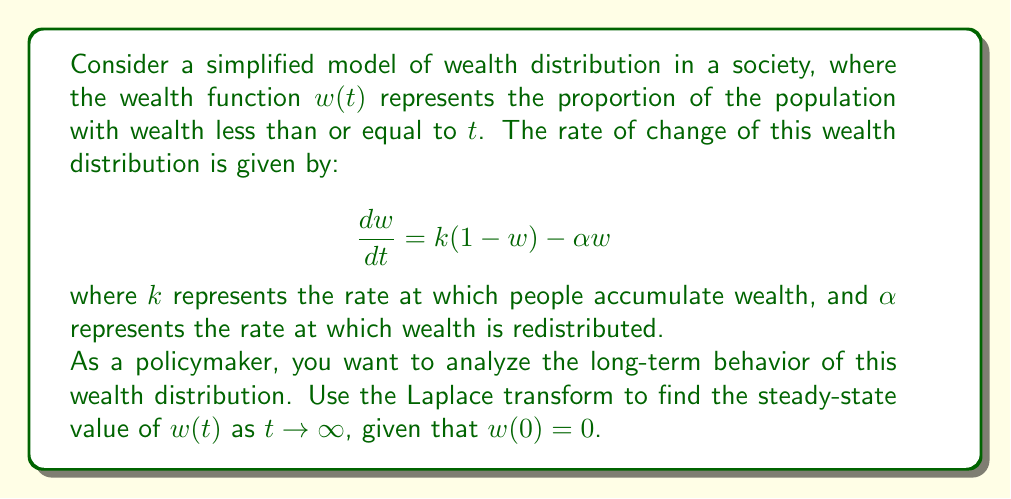Can you answer this question? To solve this problem, we'll use the Laplace transform method:

1) First, let's take the Laplace transform of both sides of the differential equation:

   $\mathcal{L}\{\frac{dw}{dt}\} = \mathcal{L}\{k(1-w) - \alpha w\}$

2) Using the linearity property and the Laplace transform of a derivative:

   $sW(s) - w(0) = \frac{k}{s} - kW(s) - \alpha W(s)$

   Where $W(s)$ is the Laplace transform of $w(t)$.

3) Given that $w(0) = 0$, we can simplify:

   $sW(s) = \frac{k}{s} - kW(s) - \alpha W(s)$

4) Rearranging terms:

   $W(s)(s + k + \alpha) = \frac{k}{s}$

5) Solving for $W(s)$:

   $W(s) = \frac{k}{s(s + k + \alpha)}$

6) This can be decomposed into partial fractions:

   $W(s) = \frac{A}{s} + \frac{B}{s + k + \alpha}$

   Where $A = \frac{k}{k + \alpha}$ and $B = -\frac{k}{k + \alpha}$

7) Taking the inverse Laplace transform:

   $w(t) = \frac{k}{k + \alpha} - \frac{k}{k + \alpha}e^{-(k + \alpha)t}$

8) To find the steady-state value, we take the limit as $t \to \infty$:

   $\lim_{t \to \infty} w(t) = \frac{k}{k + \alpha}$

This steady-state value represents the long-term proportion of the population with wealth less than or equal to $t$.
Answer: The steady-state value of the wealth distribution function $w(t)$ as $t \to \infty$ is:

$$w_{\infty} = \frac{k}{k + \alpha}$$ 